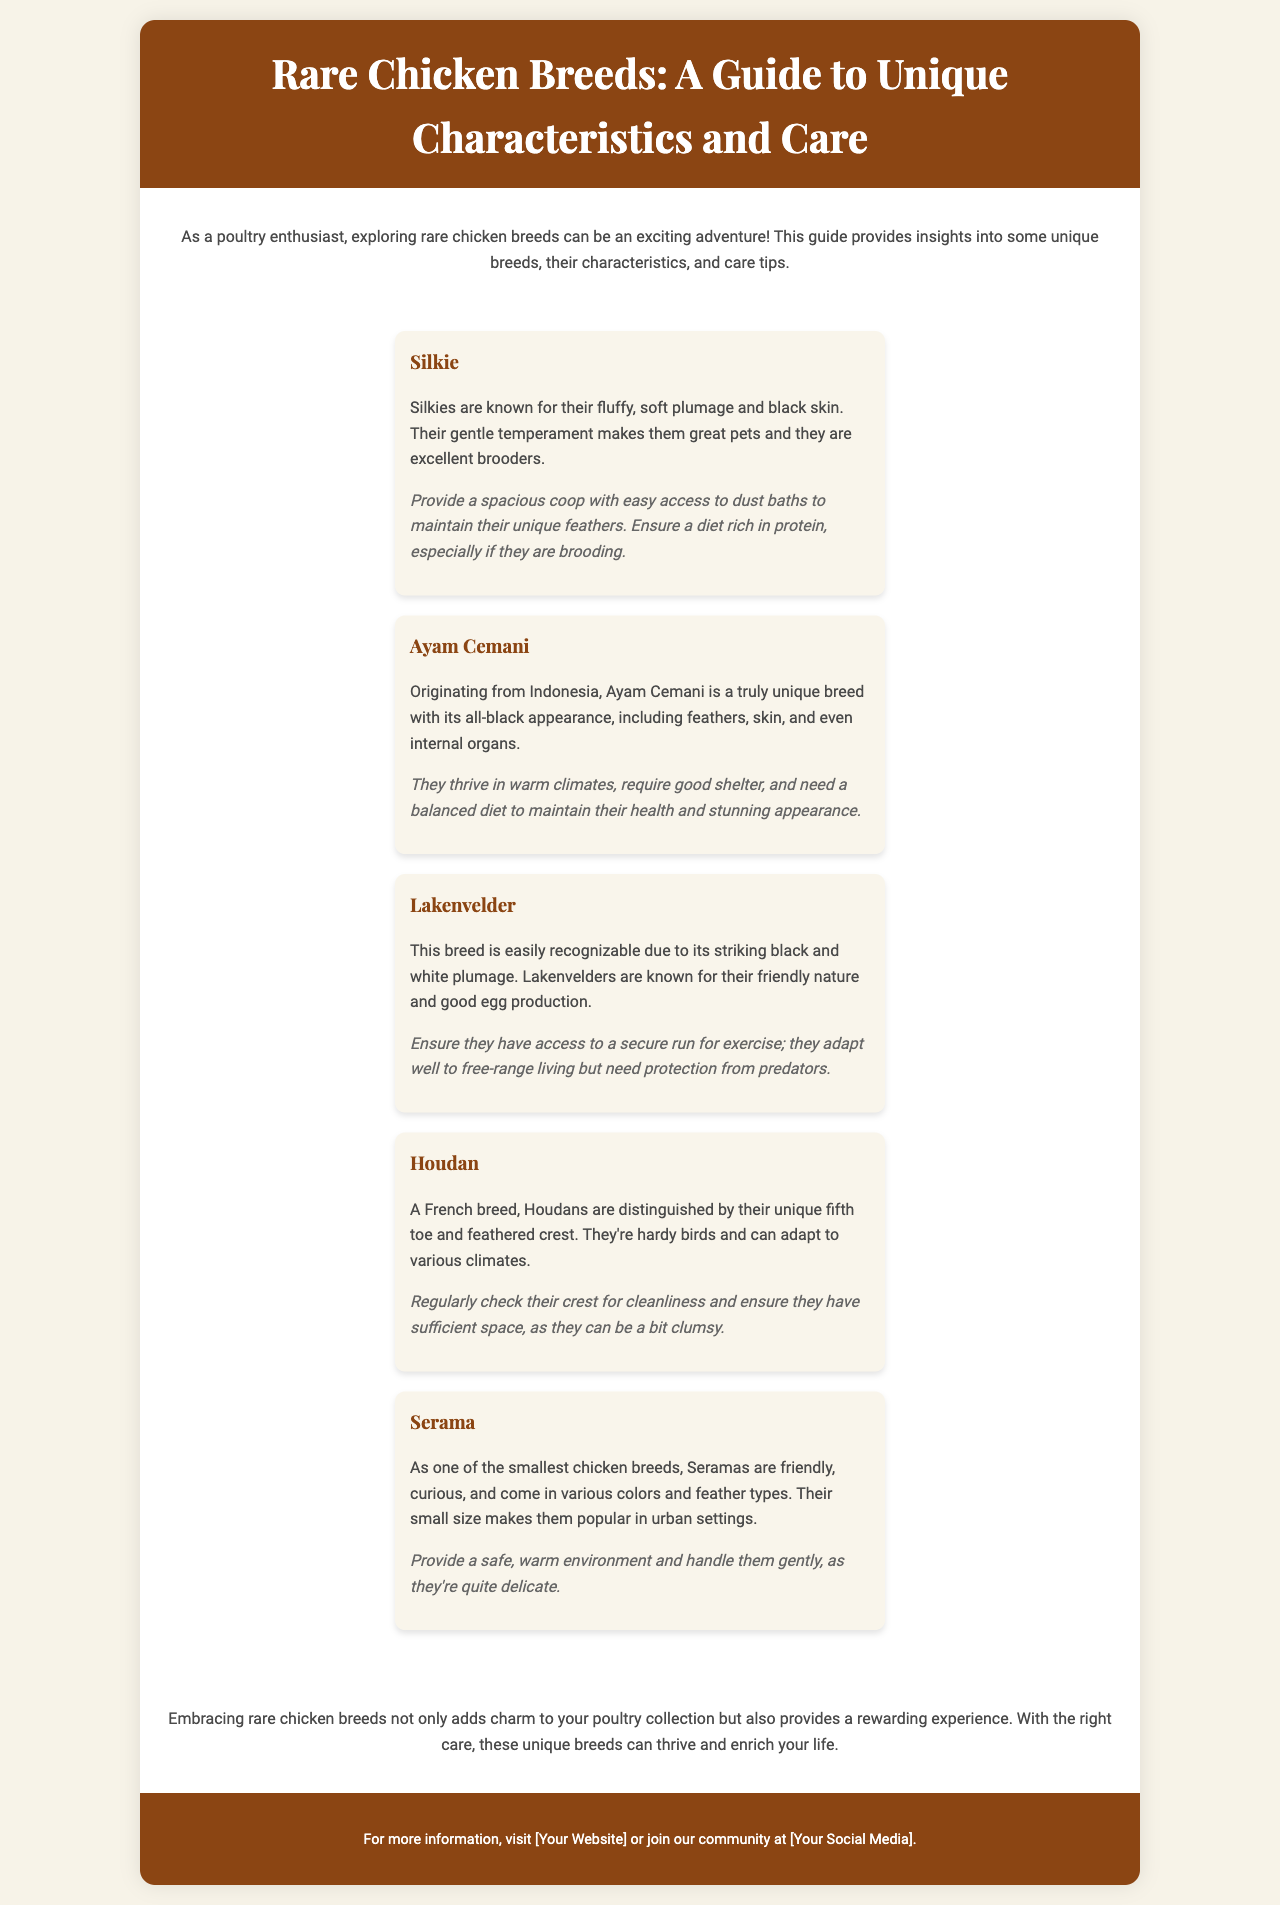what are the unique characteristics of Silkies? Silkies are known for their fluffy, soft plumage and black skin.
Answer: fluffy, soft plumage and black skin what breed is recognized by its all-black appearance? The Ayam Cemani is known for its unique all-black appearance.
Answer: Ayam Cemani how many different breeding types does the Serama have? The Serama comes in various colors and feather types.
Answer: various colors and feather types what is the main benefit of keeping Lakenvelder chickens? Lakenvelders are known for their friendly nature and good egg production.
Answer: friendly nature and good egg production what type of environment do Ayam Cemani chickens require? They thrive in warm climates and require good shelter.
Answer: warm climates and good shelter what special feature distinguishes Houdan chickens? Houdans are distinguished by their unique fifth toe and feathered crest.
Answer: fifth toe and feathered crest what type of care is recommended for Serama chickens? Provide a safe, warm environment and handle them gently, as they're quite delicate.
Answer: safe, warm environment and gentle handling how does embracing rare chicken breeds benefit a poultry enthusiast? Embracing rare chicken breeds provides a rewarding experience and adds charm to your collection.
Answer: rewarding experience and charm 